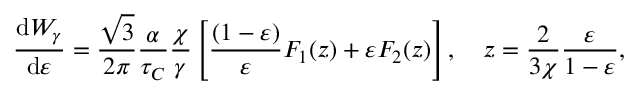<formula> <loc_0><loc_0><loc_500><loc_500>\frac { d W _ { \gamma } } { d \varepsilon } = \frac { \sqrt { 3 } } { 2 \pi } \frac { \alpha } { \tau _ { C } } \frac { \chi } { \gamma } \left [ \frac { ( 1 - \varepsilon ) } { \varepsilon } F _ { 1 } ( z ) + \varepsilon F _ { 2 } ( z ) \right ] , \quad z = \frac { 2 } { 3 \chi } \frac { \varepsilon } { 1 - \varepsilon } ,</formula> 